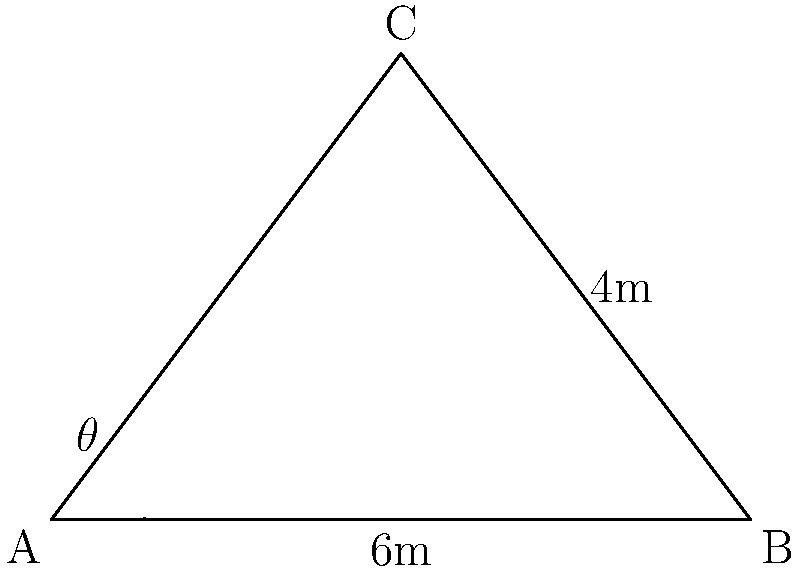A striker attempts a cheeky chip shot from point B towards the goal at point A. The goalkeeper, positioned at point C, needs to dive to save the shot. If the distance between the striker and the goal is 6 meters, and the goalkeeper is 4 meters away from the goal line, what is the angle $\theta$ (in degrees) at which the goalkeeper must dive to intercept the ball? To solve this problem, we'll use trigonometry in the right-angled triangle ABC:

1) First, we need to find the length of AC using the Pythagorean theorem:
   $AC^2 = AB^2 + BC^2$
   $AC^2 = 6^2 + 4^2 = 36 + 16 = 52$
   $AC = \sqrt{52} \approx 7.21$ meters

2) Now we can use the inverse tangent (arctan) function to find the angle $\theta$:
   $\tan(\theta) = \frac{opposite}{adjacent} = \frac{BC}{AB} = \frac{4}{6} = \frac{2}{3}$

3) Therefore:
   $\theta = \arctan(\frac{2}{3})$

4) Converting to degrees:
   $\theta = \arctan(\frac{2}{3}) \times \frac{180}{\pi} \approx 33.69°$

The goalkeeper must dive at an angle of approximately 33.69° to intercept the cheeky chip shot.
Answer: $33.69°$ 